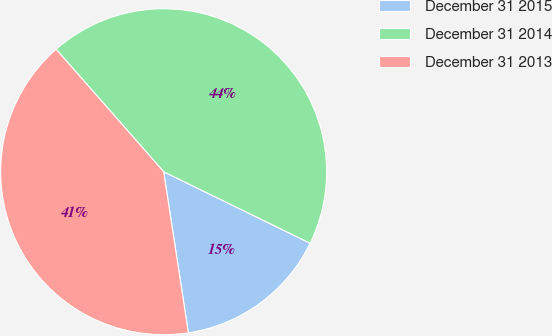Convert chart. <chart><loc_0><loc_0><loc_500><loc_500><pie_chart><fcel>December 31 2015<fcel>December 31 2014<fcel>December 31 2013<nl><fcel>15.35%<fcel>43.7%<fcel>40.95%<nl></chart> 